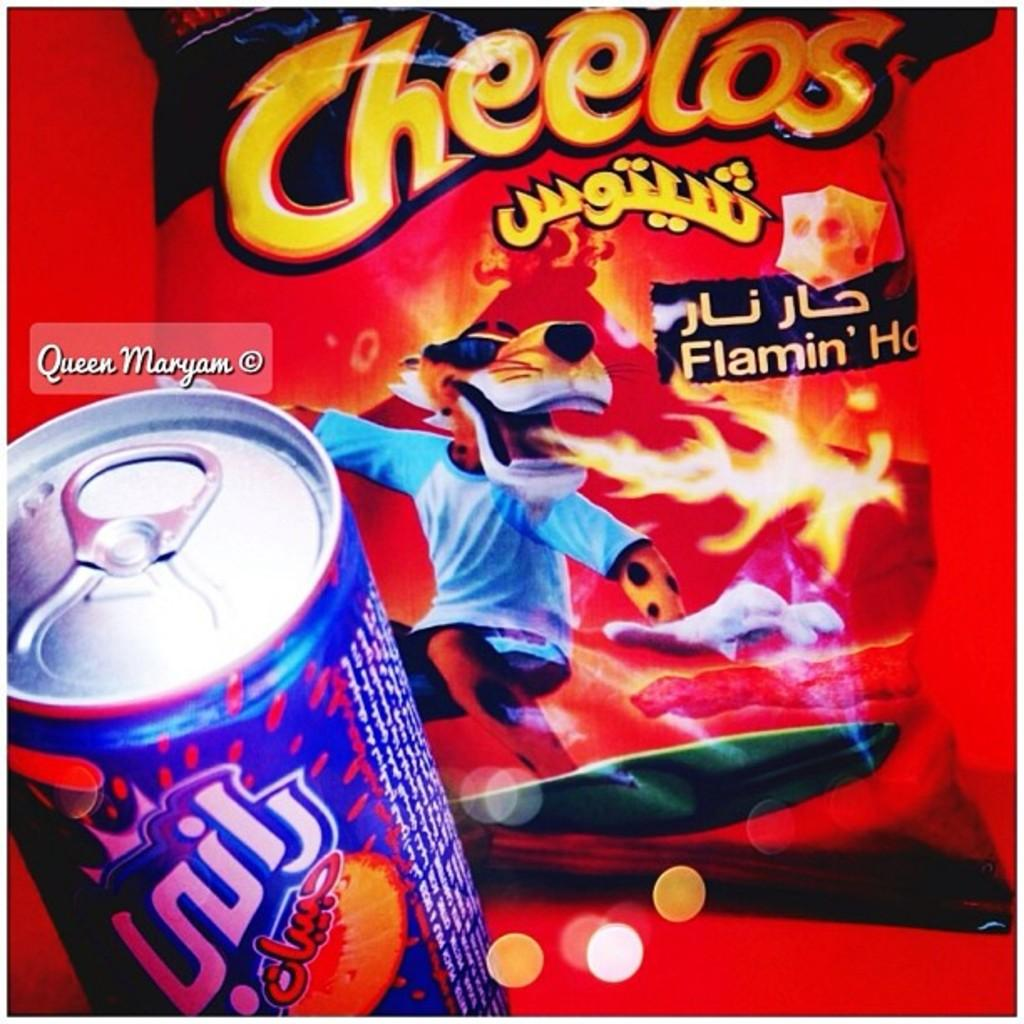<image>
Describe the image concisely. a close up of Cheetos with arabic writing and a soda 